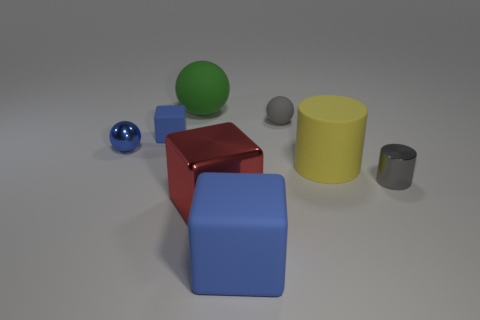Subtract all brown cylinders. How many blue blocks are left? 2 Subtract all rubber blocks. How many blocks are left? 1 Subtract 1 blocks. How many blocks are left? 2 Add 1 tiny metallic spheres. How many objects exist? 9 Subtract all cubes. How many objects are left? 5 Subtract all tiny cyan metal things. Subtract all gray rubber things. How many objects are left? 7 Add 7 large green rubber objects. How many large green rubber objects are left? 8 Add 3 big red things. How many big red things exist? 4 Subtract 0 red spheres. How many objects are left? 8 